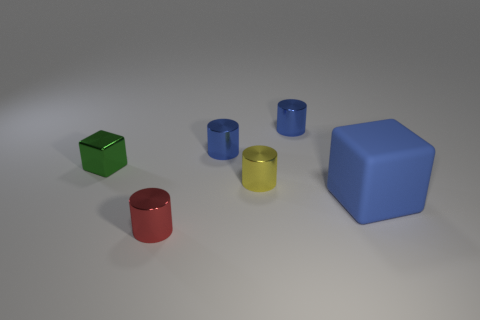Are there any other objects of the same shape as the large blue thing?
Your response must be concise. Yes. There is a tiny shiny thing in front of the blue thing in front of the green metal object; is there a metallic block on the left side of it?
Ensure brevity in your answer.  Yes. What shape is the red object that is the same size as the yellow thing?
Offer a very short reply. Cylinder. There is a metallic thing that is the same shape as the large rubber thing; what color is it?
Offer a very short reply. Green. What number of objects are either cylinders or yellow cylinders?
Your answer should be very brief. 4. There is a large object on the right side of the small red shiny object; is it the same shape as the metallic object that is to the left of the red metal object?
Your answer should be very brief. Yes. There is a tiny object on the left side of the red metal cylinder; what shape is it?
Make the answer very short. Cube. Are there an equal number of large rubber blocks that are left of the green block and shiny cylinders that are behind the blue cube?
Offer a very short reply. No. What number of things are either big blue spheres or metal cylinders behind the small red thing?
Your response must be concise. 3. What shape is the tiny metal thing that is both on the left side of the tiny yellow metal cylinder and behind the green metal thing?
Your response must be concise. Cylinder. 